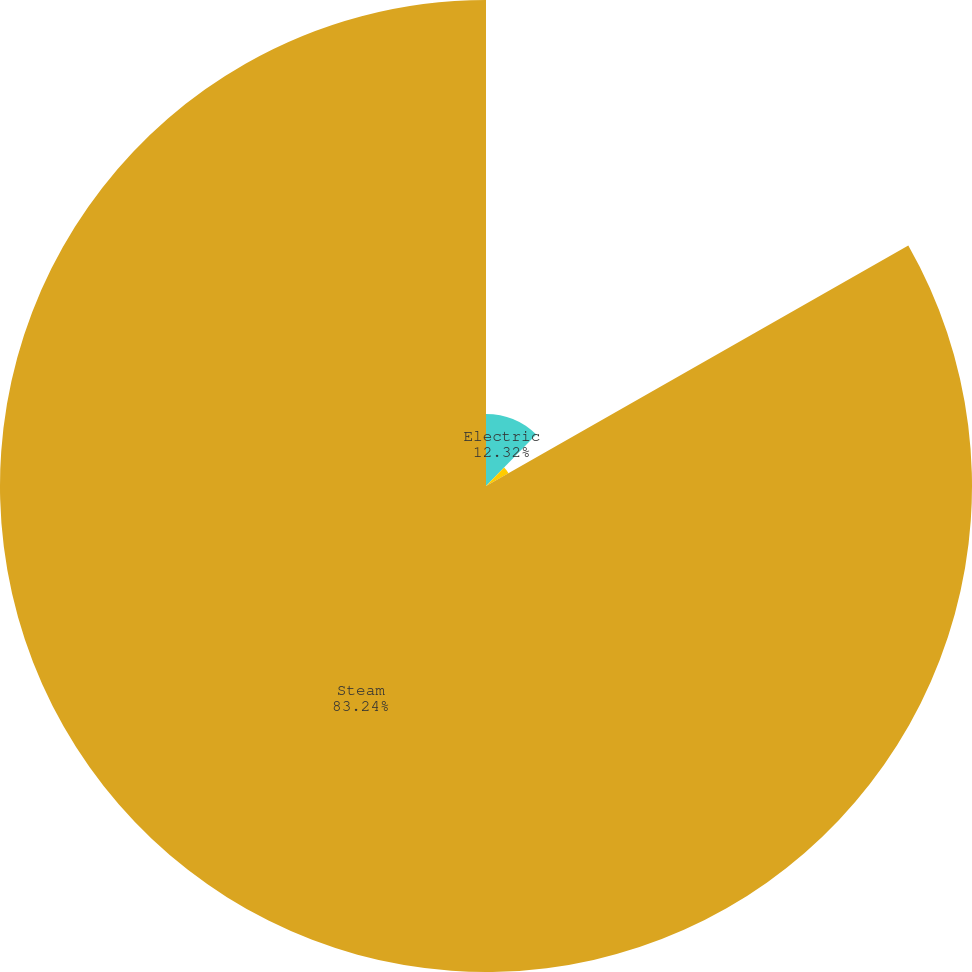Convert chart to OTSL. <chart><loc_0><loc_0><loc_500><loc_500><pie_chart><fcel>Electric<fcel>Gas<fcel>Steam<nl><fcel>12.32%<fcel>4.44%<fcel>83.24%<nl></chart> 